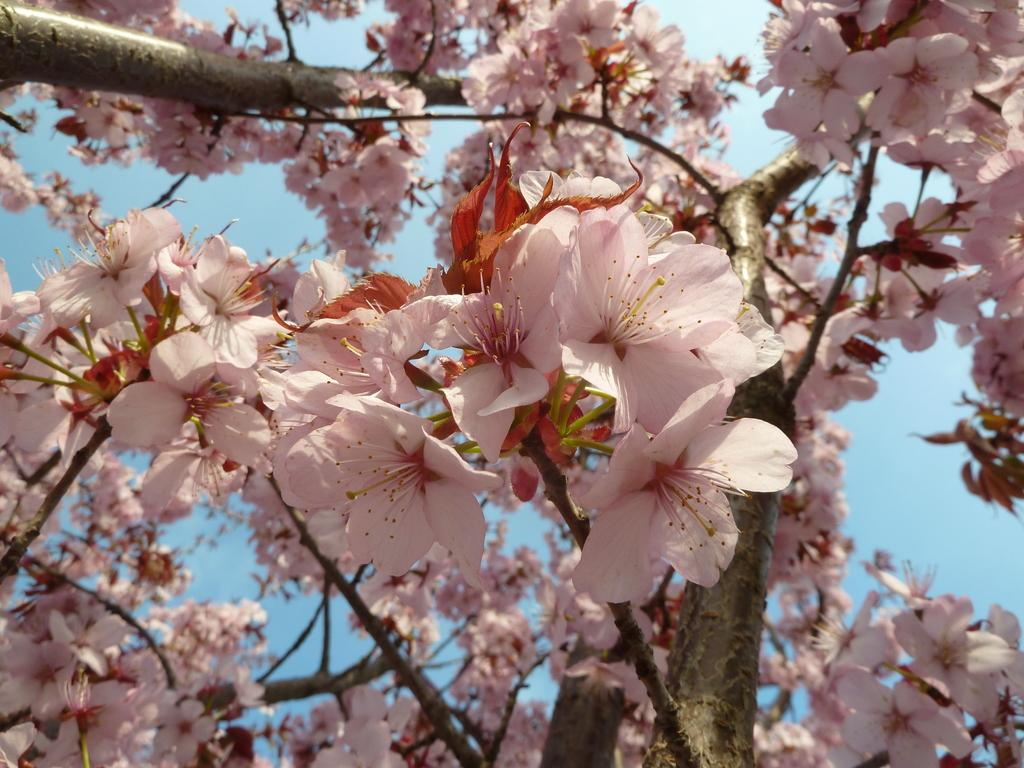What type of living organisms can be seen in the image? Flowers can be seen in the image. What type of ornament is hanging from the flowers in the image? There is no ornament present in the image; it only features flowers. 